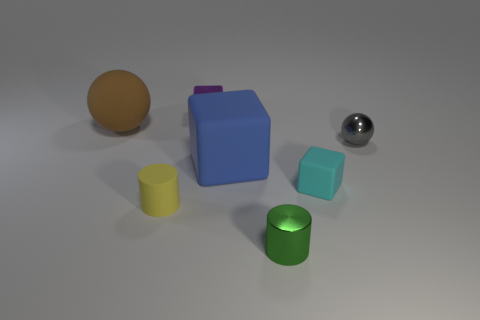What is the material of the object to the far left? The object to the far left seems to be made of a matte material, possibly resembling rubber or a soft plastic, indicated by its non-reflective surface. 